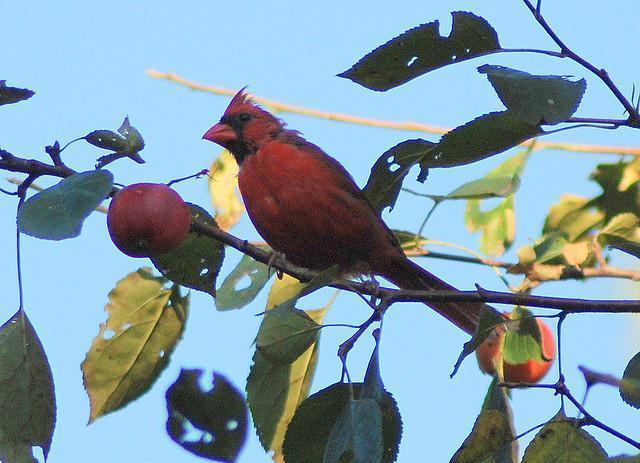How many apples are there?
Give a very brief answer. 2. How many buses are on the street?
Give a very brief answer. 0. 